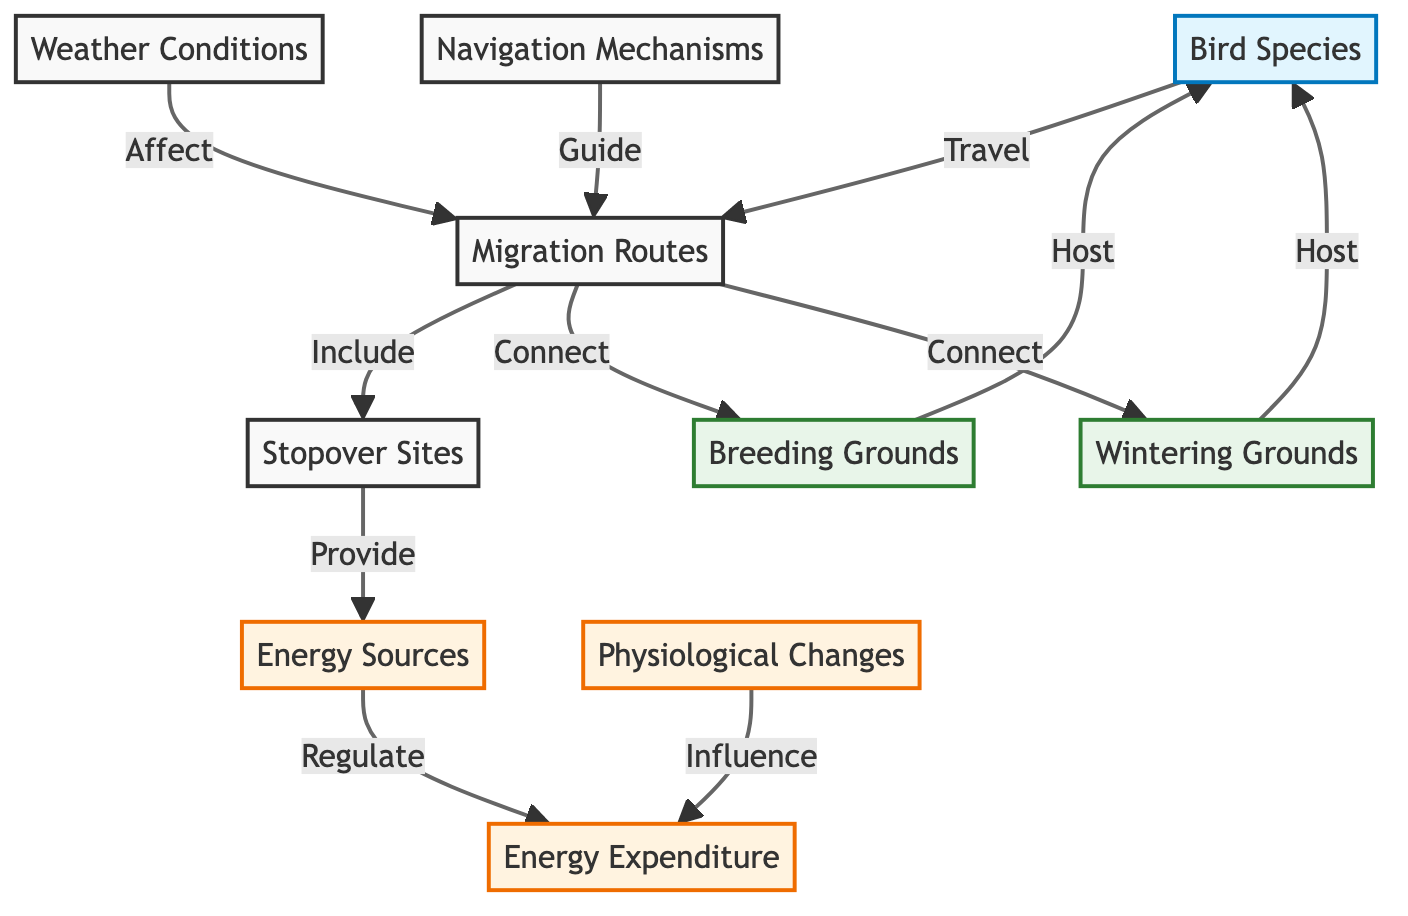What are the two types of grounds connected by migration routes? The diagram indicates that migration routes connect breeding grounds and wintering grounds, as represented in the nodes.
Answer: breeding grounds and wintering grounds How do stopover sites contribute to the migration process? According to the diagram, stopover sites provide energy sources, which are essential for the migration journey, highlighting their role in supporting birds during migration.
Answer: provide energy sources What is influenced by physiological changes? The diagram shows that physiological changes influence energy expenditure, indicating that the metabolic state of birds affects how much energy they use during migration.
Answer: energy expenditure Which elements guide the migration routes? The diagram specifies that navigation mechanisms guide migration routes, suggesting these are the factors that help birds determine their paths during migration.
Answer: navigation mechanisms What factor affects migration routes according to the diagram? The diagram illustrates that weather conditions affect migration routes, indicating environmental factors play a significant role in the timing and paths of bird migration.
Answer: weather conditions How many destination nodes are present in the diagram? By analyzing the diagram, there are two destination nodes: breeding grounds and wintering grounds, making it simple to count them.
Answer: 2 